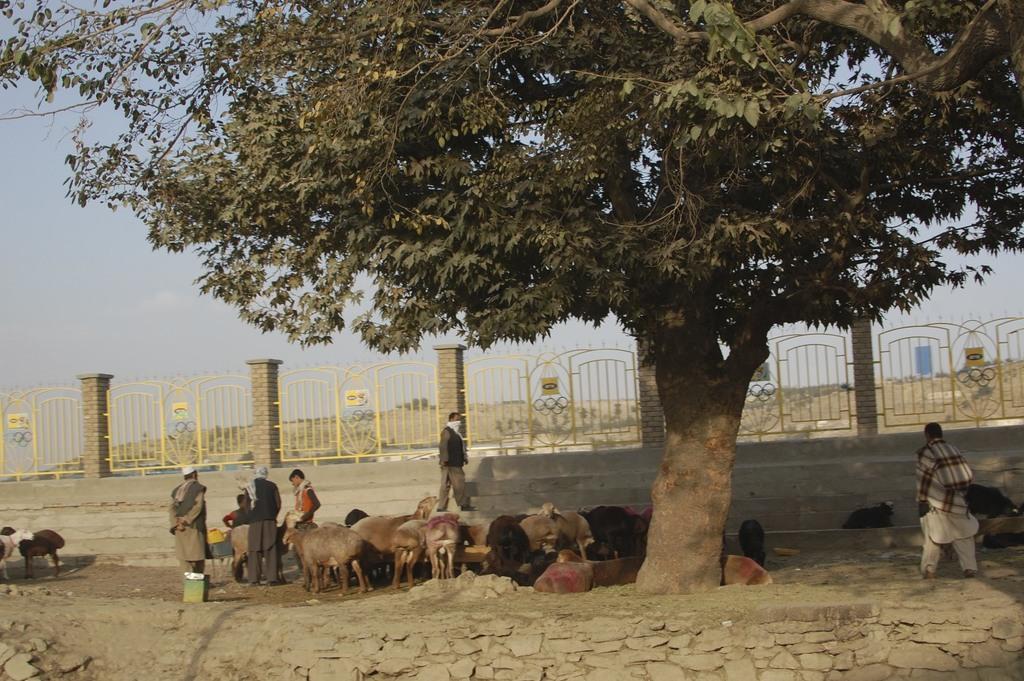Describe this image in one or two sentences. In this image I can see there are some people and animals under the tree, behind them there is a wall. 